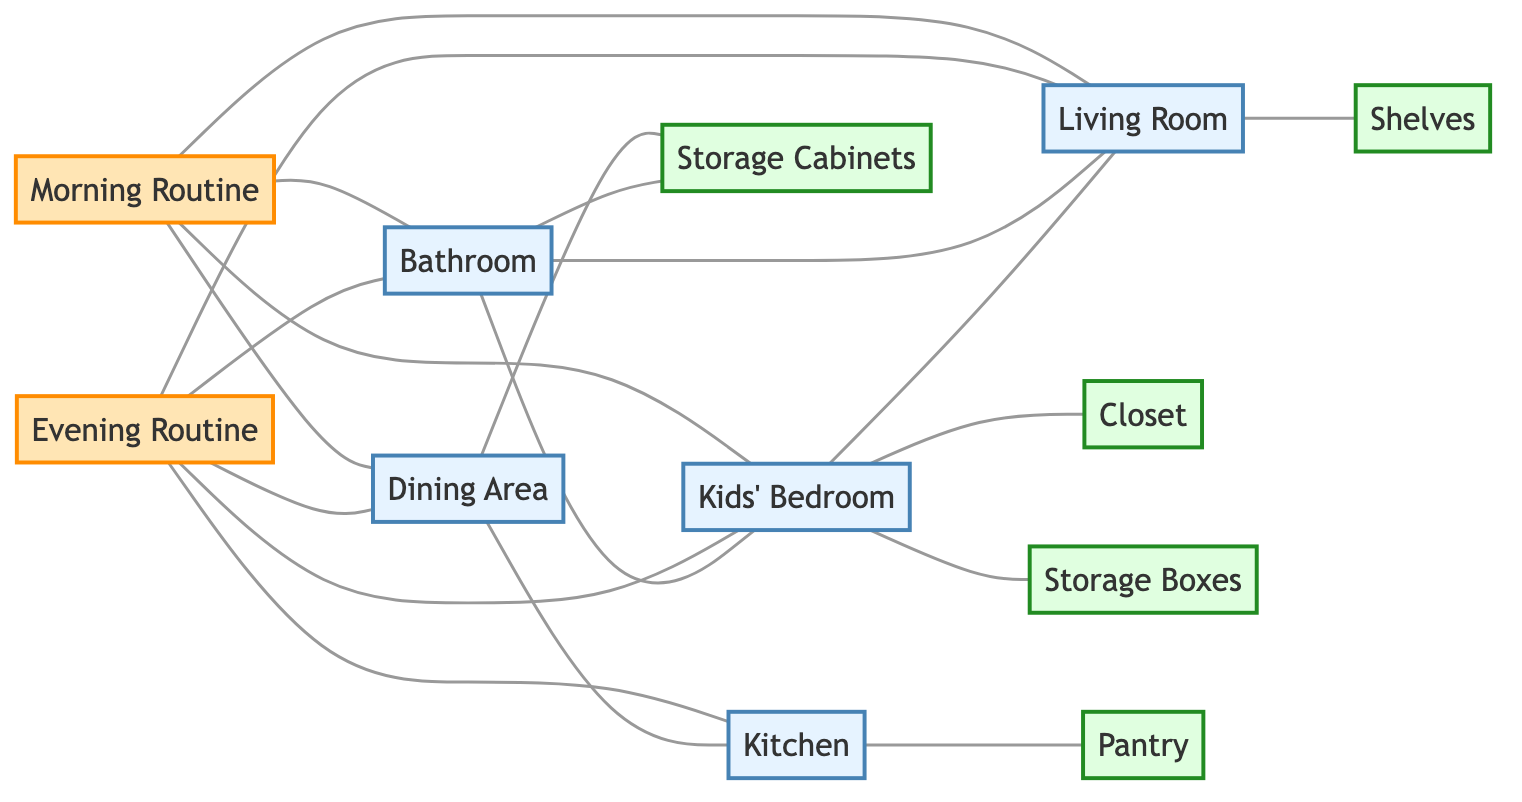What is the total number of nodes in the diagram? The diagram includes individual nodes for the "Morning Routine," "Evening Routine," and various functional spaces and storage solutions totaling 12 unique entities.
Answer: 12 Which routine is connected to the Kitchen? The "Evening Routine" is the only routine connected directly to the "Kitchen," as indicated by the direct link in the diagram.
Answer: Evening Routine How many storage solutions are represented in the diagram? There are four distinct storage solutions noted: "Storage Cabinets," "Closet," "Storage Boxes," and "Shelves" contributes to the total of storage options present.
Answer: 4 Which space connects to both the Bathroom and the Living Room? The "Kids' Bedroom" is connected to both "Bathroom" and "Living Room," making it a central hub between these two areas in the diagram.
Answer: Kids' Bedroom What space connects to both the Dining Area and Storage Cabinets? The "Dining Area" is directly linked to "Storage Cabinets," showcasing a functional relationship between the two within the context of meal and storage management.
Answer: Storage Cabinets Which routine is linked to the most spaces? The "Evening Routine" connects to five areas: "Dining Area," "Kids' Bedroom," "Living Room," "Bathroom," and "Kitchen," indicating a broader reach in daily activities compared to the "Morning Routine."
Answer: Evening Routine Which room is directly connected to the maximum number of storage solutions? The "Kids' Bedroom" connects directly to "Closet" and "Storage Boxes," indicating that this room incorporates the most storage options among all spaces.
Answer: Kids' Bedroom Which two routines share no common connections? "Morning Routine" and "Kitchen" do not share any direct connections; thus, they operate independently of each other in the daily routines context.
Answer: Morning Routine & Kitchen How many edges connect the Living Room to other nodes? The "Living Room" connects to four other nodes: "Kids' Bedroom," "Bathroom," "Dining Area," and "Shelves," revealing its role within the home's layout.
Answer: 4 